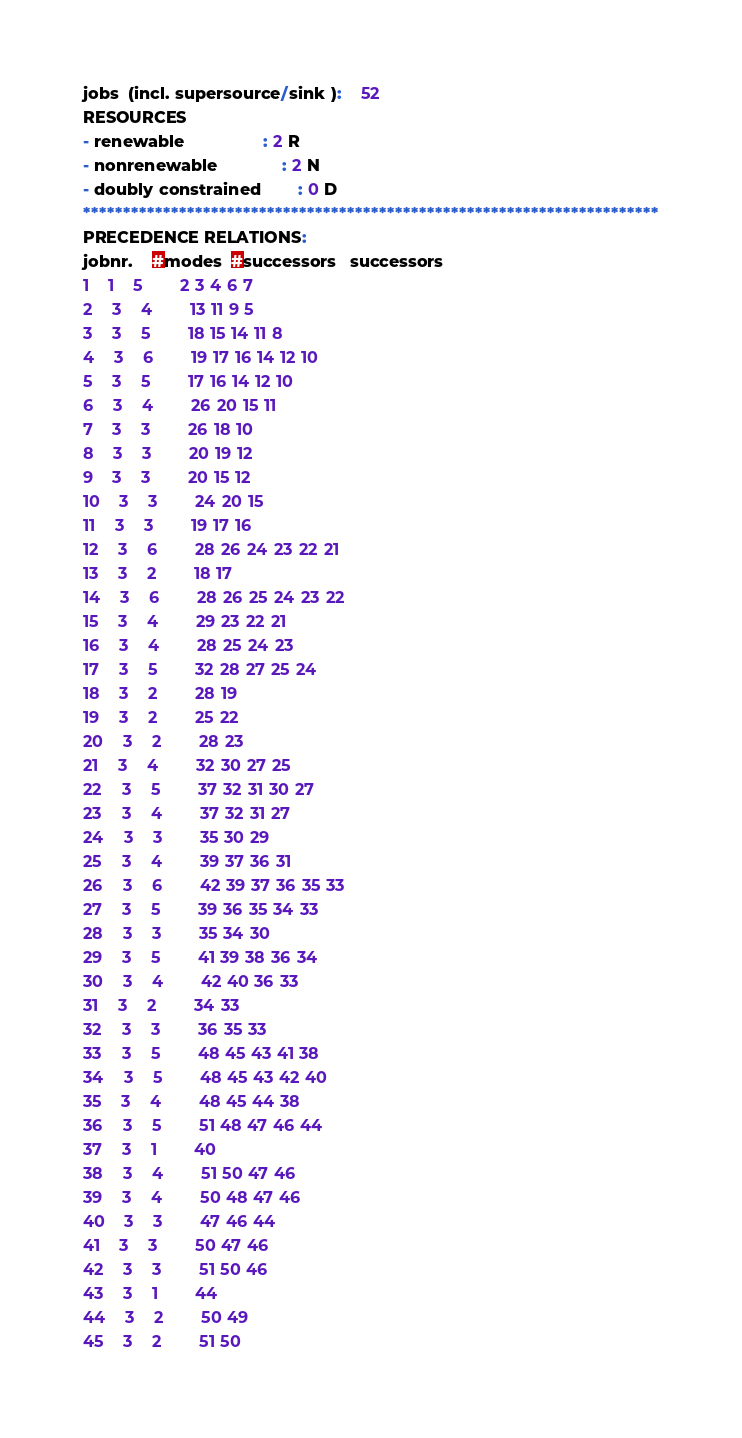Convert code to text. <code><loc_0><loc_0><loc_500><loc_500><_ObjectiveC_>jobs  (incl. supersource/sink ):	52
RESOURCES
- renewable                 : 2 R
- nonrenewable              : 2 N
- doubly constrained        : 0 D
************************************************************************
PRECEDENCE RELATIONS:
jobnr.    #modes  #successors   successors
1	1	5		2 3 4 6 7 
2	3	4		13 11 9 5 
3	3	5		18 15 14 11 8 
4	3	6		19 17 16 14 12 10 
5	3	5		17 16 14 12 10 
6	3	4		26 20 15 11 
7	3	3		26 18 10 
8	3	3		20 19 12 
9	3	3		20 15 12 
10	3	3		24 20 15 
11	3	3		19 17 16 
12	3	6		28 26 24 23 22 21 
13	3	2		18 17 
14	3	6		28 26 25 24 23 22 
15	3	4		29 23 22 21 
16	3	4		28 25 24 23 
17	3	5		32 28 27 25 24 
18	3	2		28 19 
19	3	2		25 22 
20	3	2		28 23 
21	3	4		32 30 27 25 
22	3	5		37 32 31 30 27 
23	3	4		37 32 31 27 
24	3	3		35 30 29 
25	3	4		39 37 36 31 
26	3	6		42 39 37 36 35 33 
27	3	5		39 36 35 34 33 
28	3	3		35 34 30 
29	3	5		41 39 38 36 34 
30	3	4		42 40 36 33 
31	3	2		34 33 
32	3	3		36 35 33 
33	3	5		48 45 43 41 38 
34	3	5		48 45 43 42 40 
35	3	4		48 45 44 38 
36	3	5		51 48 47 46 44 
37	3	1		40 
38	3	4		51 50 47 46 
39	3	4		50 48 47 46 
40	3	3		47 46 44 
41	3	3		50 47 46 
42	3	3		51 50 46 
43	3	1		44 
44	3	2		50 49 
45	3	2		51 50 </code> 